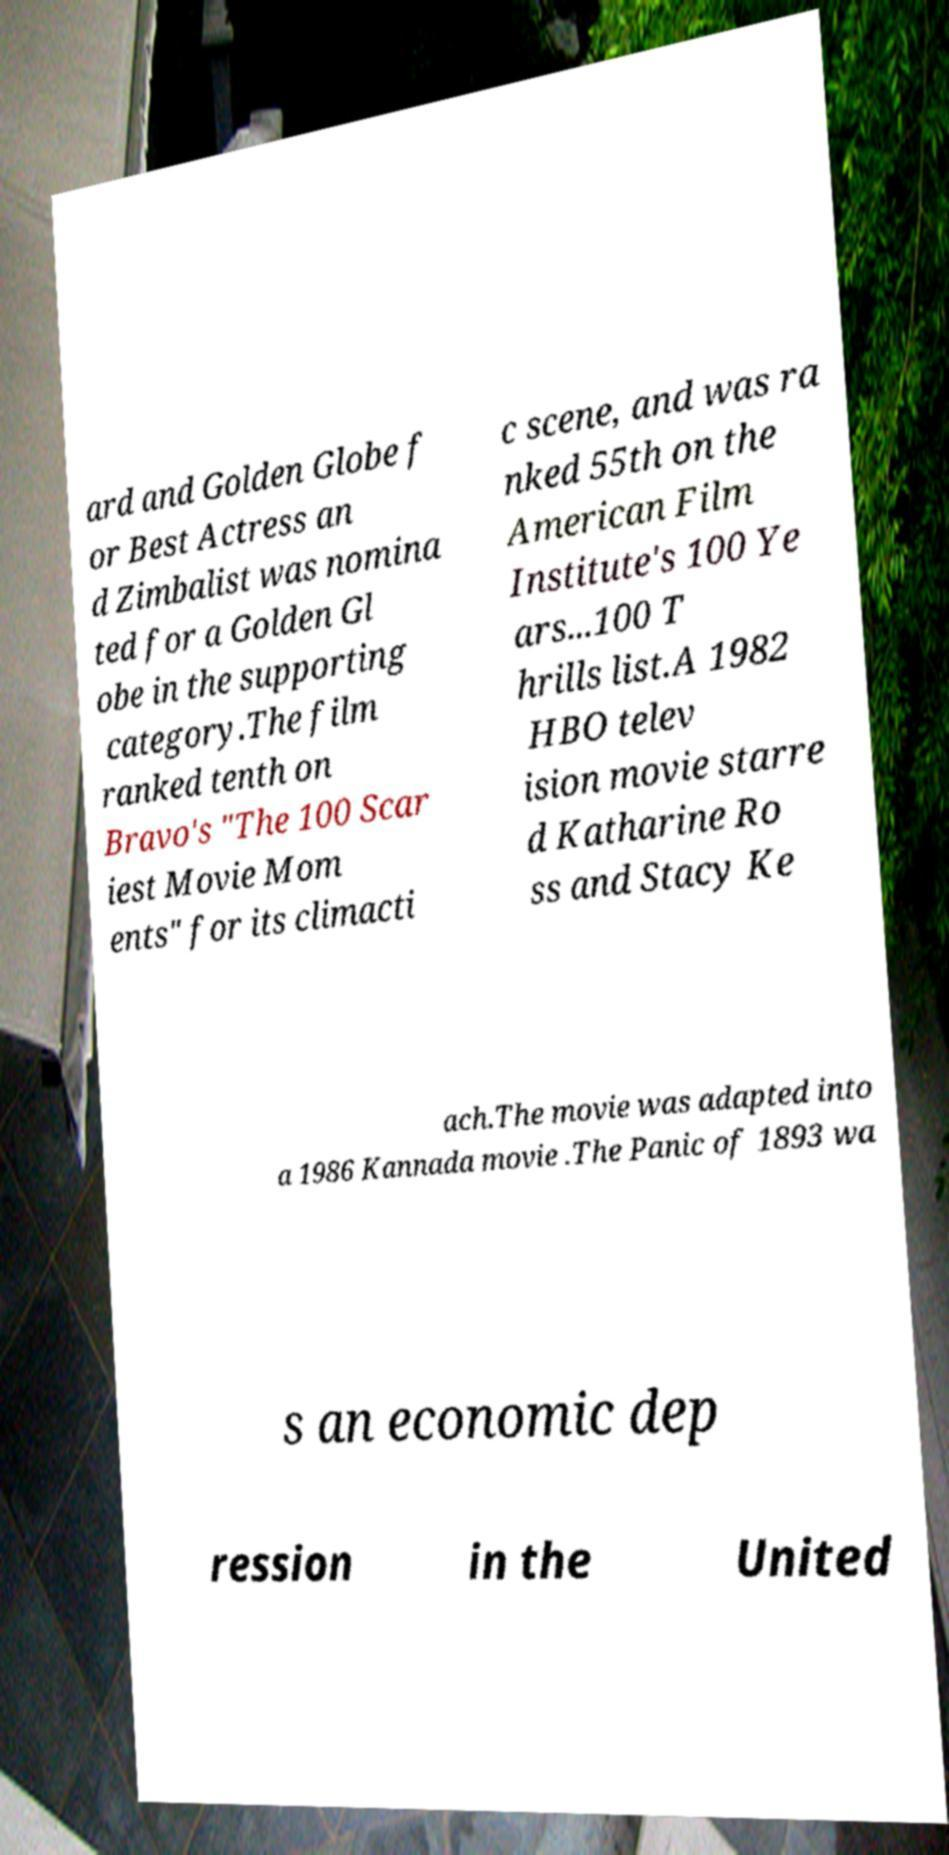Could you assist in decoding the text presented in this image and type it out clearly? ard and Golden Globe f or Best Actress an d Zimbalist was nomina ted for a Golden Gl obe in the supporting category.The film ranked tenth on Bravo's "The 100 Scar iest Movie Mom ents" for its climacti c scene, and was ra nked 55th on the American Film Institute's 100 Ye ars...100 T hrills list.A 1982 HBO telev ision movie starre d Katharine Ro ss and Stacy Ke ach.The movie was adapted into a 1986 Kannada movie .The Panic of 1893 wa s an economic dep ression in the United 